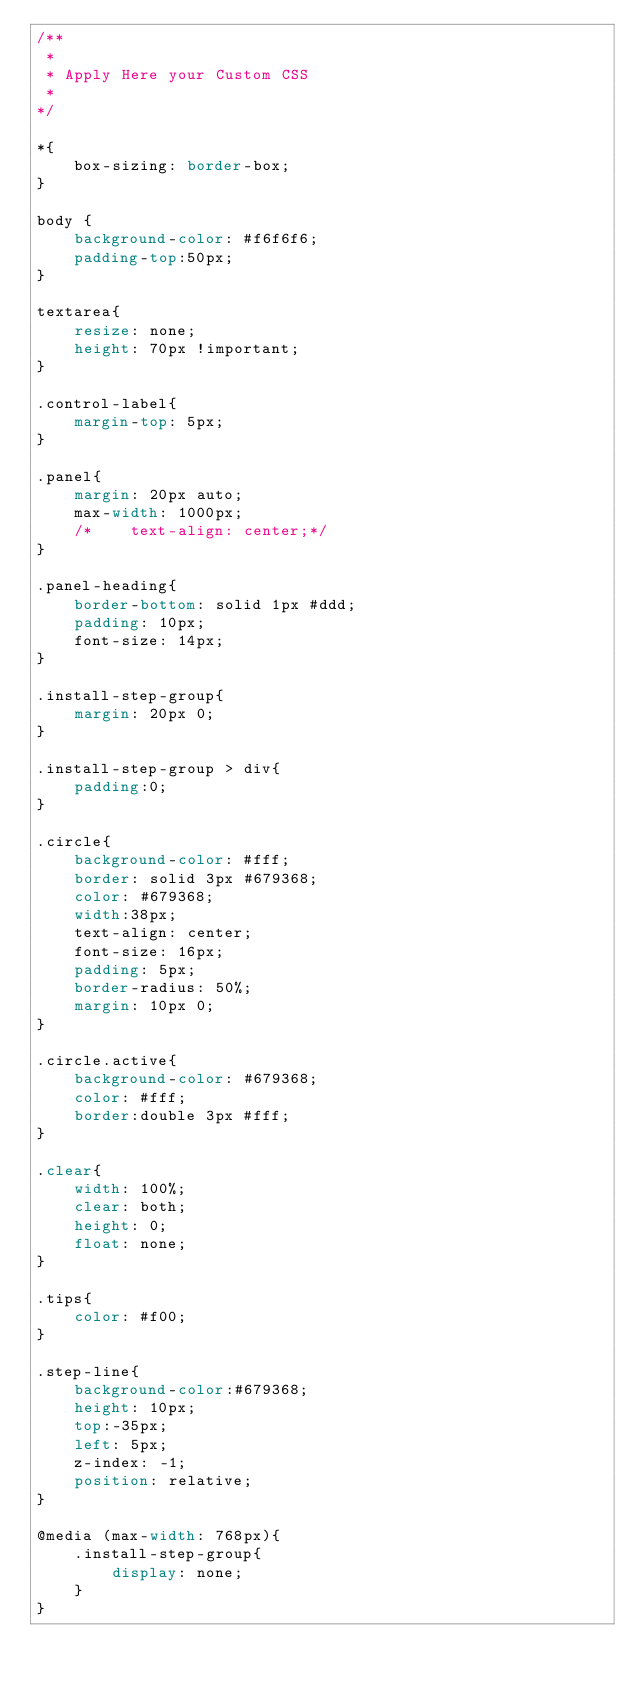Convert code to text. <code><loc_0><loc_0><loc_500><loc_500><_CSS_>/**
 *
 * Apply Here your Custom CSS
 *
*/

*{
    box-sizing: border-box;
}

body {
    background-color: #f6f6f6;
    padding-top:50px;
}

textarea{
    resize: none;
    height: 70px !important;
}

.control-label{
    margin-top: 5px;
}

.panel{
    margin: 20px auto;
    max-width: 1000px;
    /*    text-align: center;*/
}

.panel-heading{
    border-bottom: solid 1px #ddd;
    padding: 10px;
    font-size: 14px;
}

.install-step-group{
    margin: 20px 0;
}

.install-step-group > div{
    padding:0;
}

.circle{
    background-color: #fff;
    border: solid 3px #679368;
    color: #679368;
    width:38px;
    text-align: center;
    font-size: 16px;
    padding: 5px;
    border-radius: 50%;
    margin: 10px 0;
}

.circle.active{
    background-color: #679368;
    color: #fff;
    border:double 3px #fff;
}

.clear{
    width: 100%;
    clear: both;
    height: 0;
    float: none;
}

.tips{
    color: #f00;
}

.step-line{
    background-color:#679368;
    height: 10px;
    top:-35px;
    left: 5px;
    z-index: -1;
    position: relative;
}

@media (max-width: 768px){
    .install-step-group{
        display: none;
    }
}</code> 